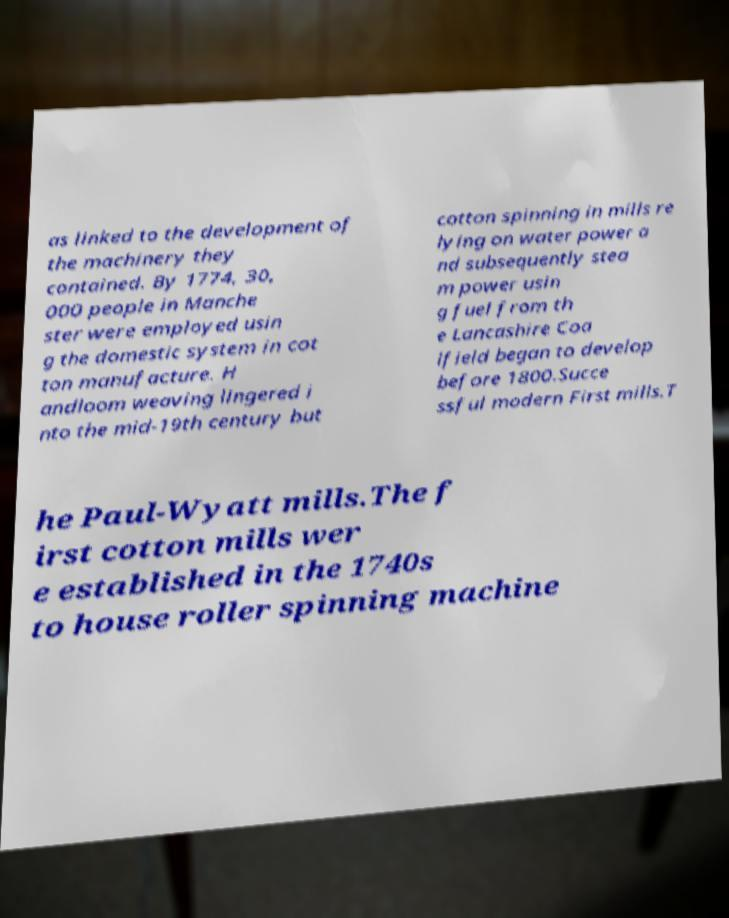For documentation purposes, I need the text within this image transcribed. Could you provide that? as linked to the development of the machinery they contained. By 1774, 30, 000 people in Manche ster were employed usin g the domestic system in cot ton manufacture. H andloom weaving lingered i nto the mid-19th century but cotton spinning in mills re lying on water power a nd subsequently stea m power usin g fuel from th e Lancashire Coa lfield began to develop before 1800.Succe ssful modern First mills.T he Paul-Wyatt mills.The f irst cotton mills wer e established in the 1740s to house roller spinning machine 